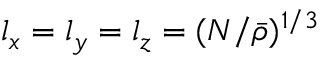<formula> <loc_0><loc_0><loc_500><loc_500>l _ { x } = l _ { y } = l _ { z } = ( N / \bar { \rho } ) ^ { 1 / 3 }</formula> 